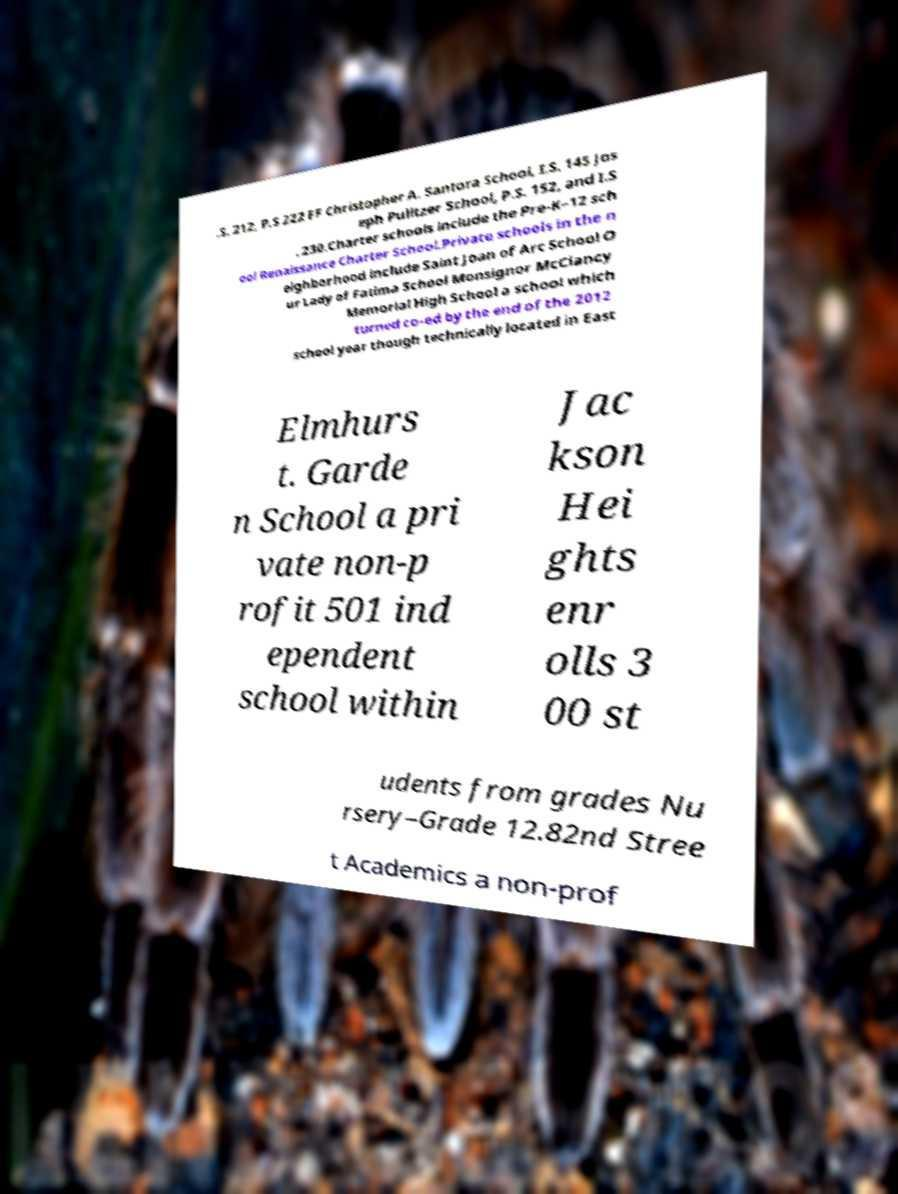Could you assist in decoding the text presented in this image and type it out clearly? .S. 212, P.S 222 FF Christopher A. Santora School, I.S. 145 Jos eph Pulitzer School, P.S. 152, and I.S . 230.Charter schools include the Pre-K–12 sch ool Renaissance Charter School.Private schools in the n eighborhood include Saint Joan of Arc School O ur Lady of Fatima School Monsignor McClancy Memorial High School a school which turned co-ed by the end of the 2012 school year though technically located in East Elmhurs t. Garde n School a pri vate non-p rofit 501 ind ependent school within Jac kson Hei ghts enr olls 3 00 st udents from grades Nu rsery–Grade 12.82nd Stree t Academics a non-prof 